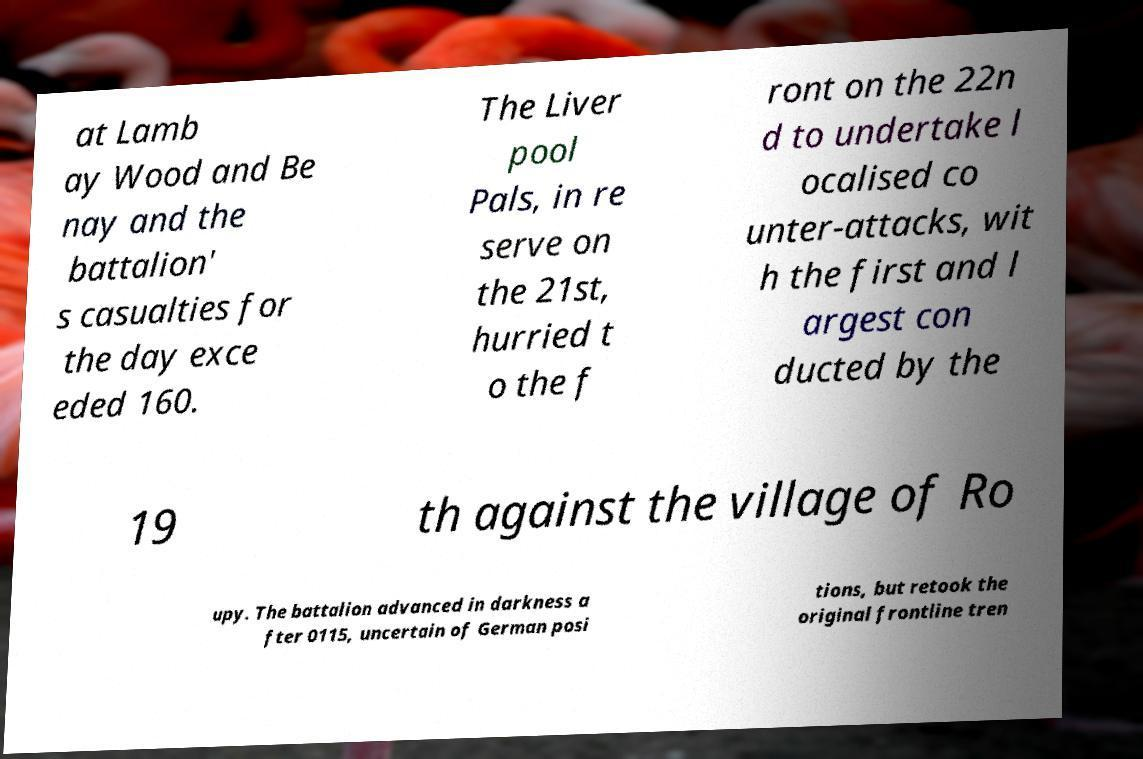Could you extract and type out the text from this image? at Lamb ay Wood and Be nay and the battalion' s casualties for the day exce eded 160. The Liver pool Pals, in re serve on the 21st, hurried t o the f ront on the 22n d to undertake l ocalised co unter-attacks, wit h the first and l argest con ducted by the 19 th against the village of Ro upy. The battalion advanced in darkness a fter 0115, uncertain of German posi tions, but retook the original frontline tren 